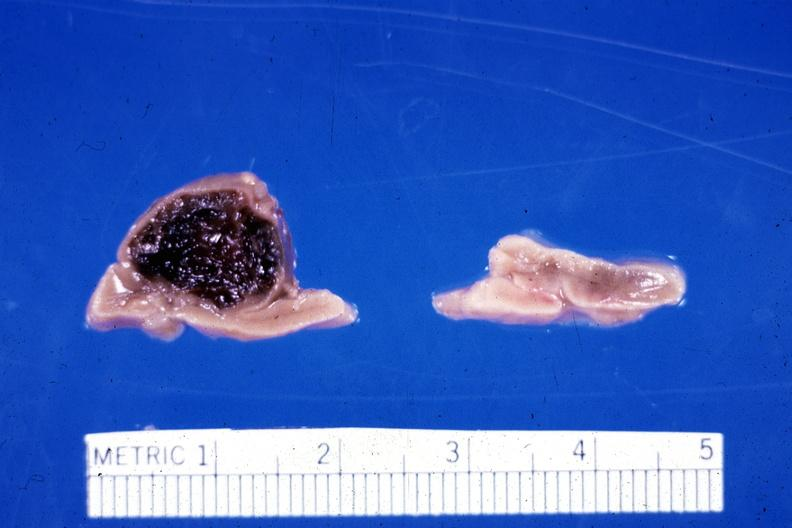what is present?
Answer the question using a single word or phrase. Hemorrhage in newborn 